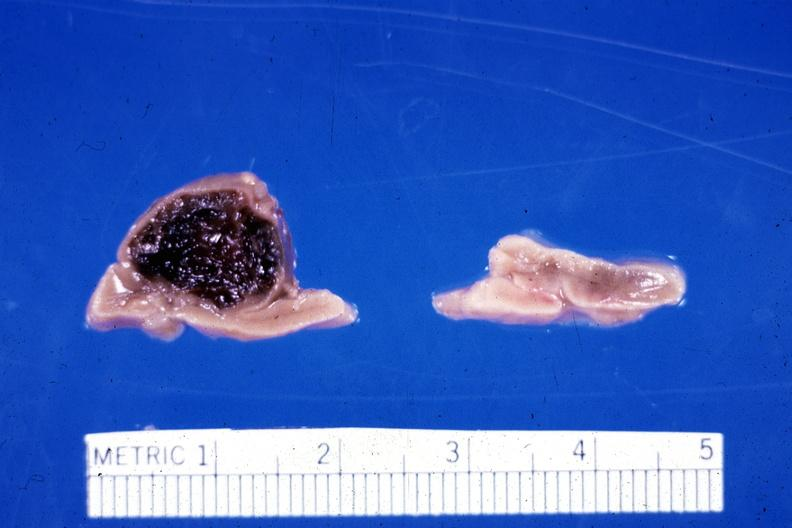what is present?
Answer the question using a single word or phrase. Hemorrhage in newborn 